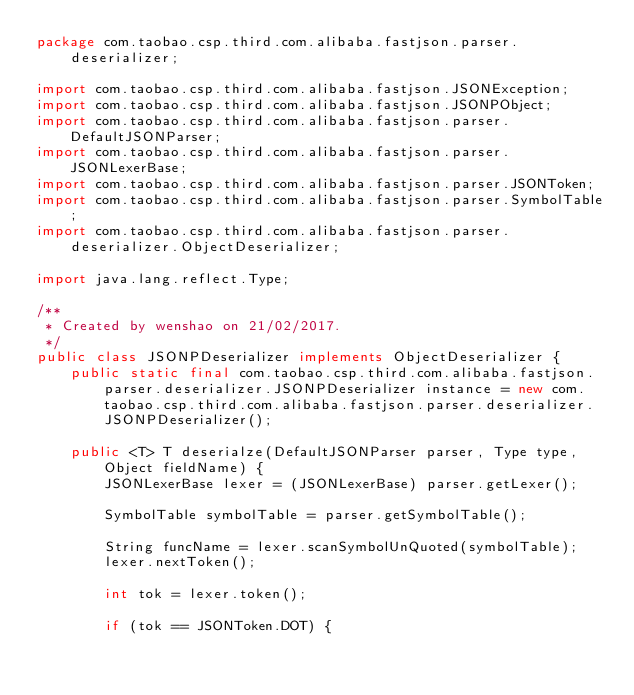<code> <loc_0><loc_0><loc_500><loc_500><_Java_>package com.taobao.csp.third.com.alibaba.fastjson.parser.deserializer;

import com.taobao.csp.third.com.alibaba.fastjson.JSONException;
import com.taobao.csp.third.com.alibaba.fastjson.JSONPObject;
import com.taobao.csp.third.com.alibaba.fastjson.parser.DefaultJSONParser;
import com.taobao.csp.third.com.alibaba.fastjson.parser.JSONLexerBase;
import com.taobao.csp.third.com.alibaba.fastjson.parser.JSONToken;
import com.taobao.csp.third.com.alibaba.fastjson.parser.SymbolTable;
import com.taobao.csp.third.com.alibaba.fastjson.parser.deserializer.ObjectDeserializer;

import java.lang.reflect.Type;

/**
 * Created by wenshao on 21/02/2017.
 */
public class JSONPDeserializer implements ObjectDeserializer {
    public static final com.taobao.csp.third.com.alibaba.fastjson.parser.deserializer.JSONPDeserializer instance = new com.taobao.csp.third.com.alibaba.fastjson.parser.deserializer.JSONPDeserializer();

    public <T> T deserialze(DefaultJSONParser parser, Type type, Object fieldName) {
        JSONLexerBase lexer = (JSONLexerBase) parser.getLexer();

        SymbolTable symbolTable = parser.getSymbolTable();

        String funcName = lexer.scanSymbolUnQuoted(symbolTable);
        lexer.nextToken();

        int tok = lexer.token();

        if (tok == JSONToken.DOT) {</code> 